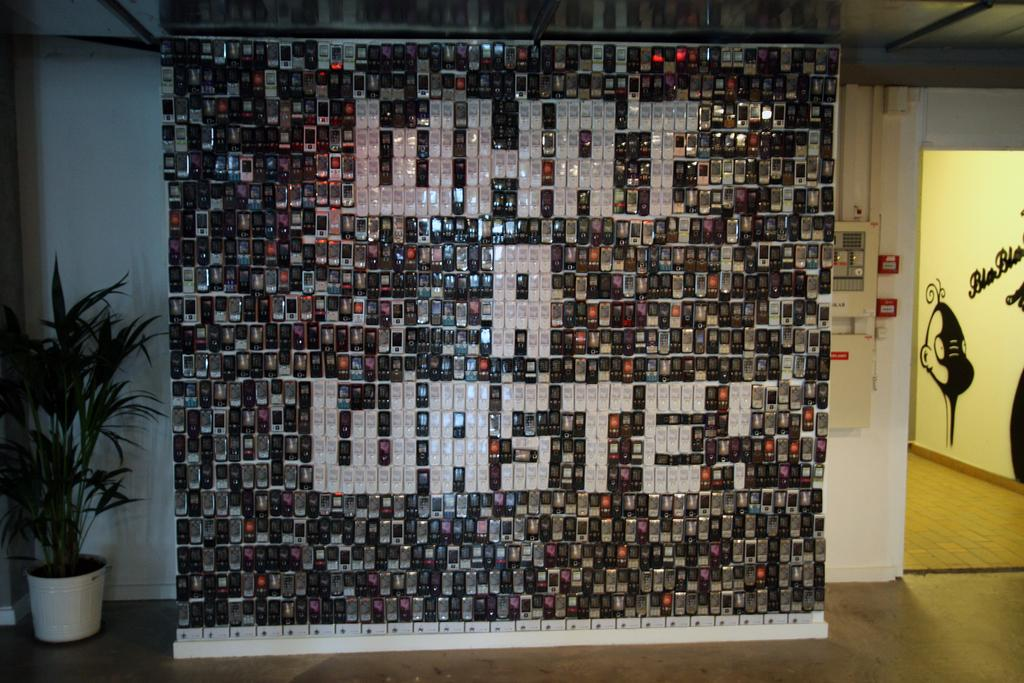<image>
Summarize the visual content of the image. A huge number of cell phones have been used to create a message on a wall which reads What a Waste! 